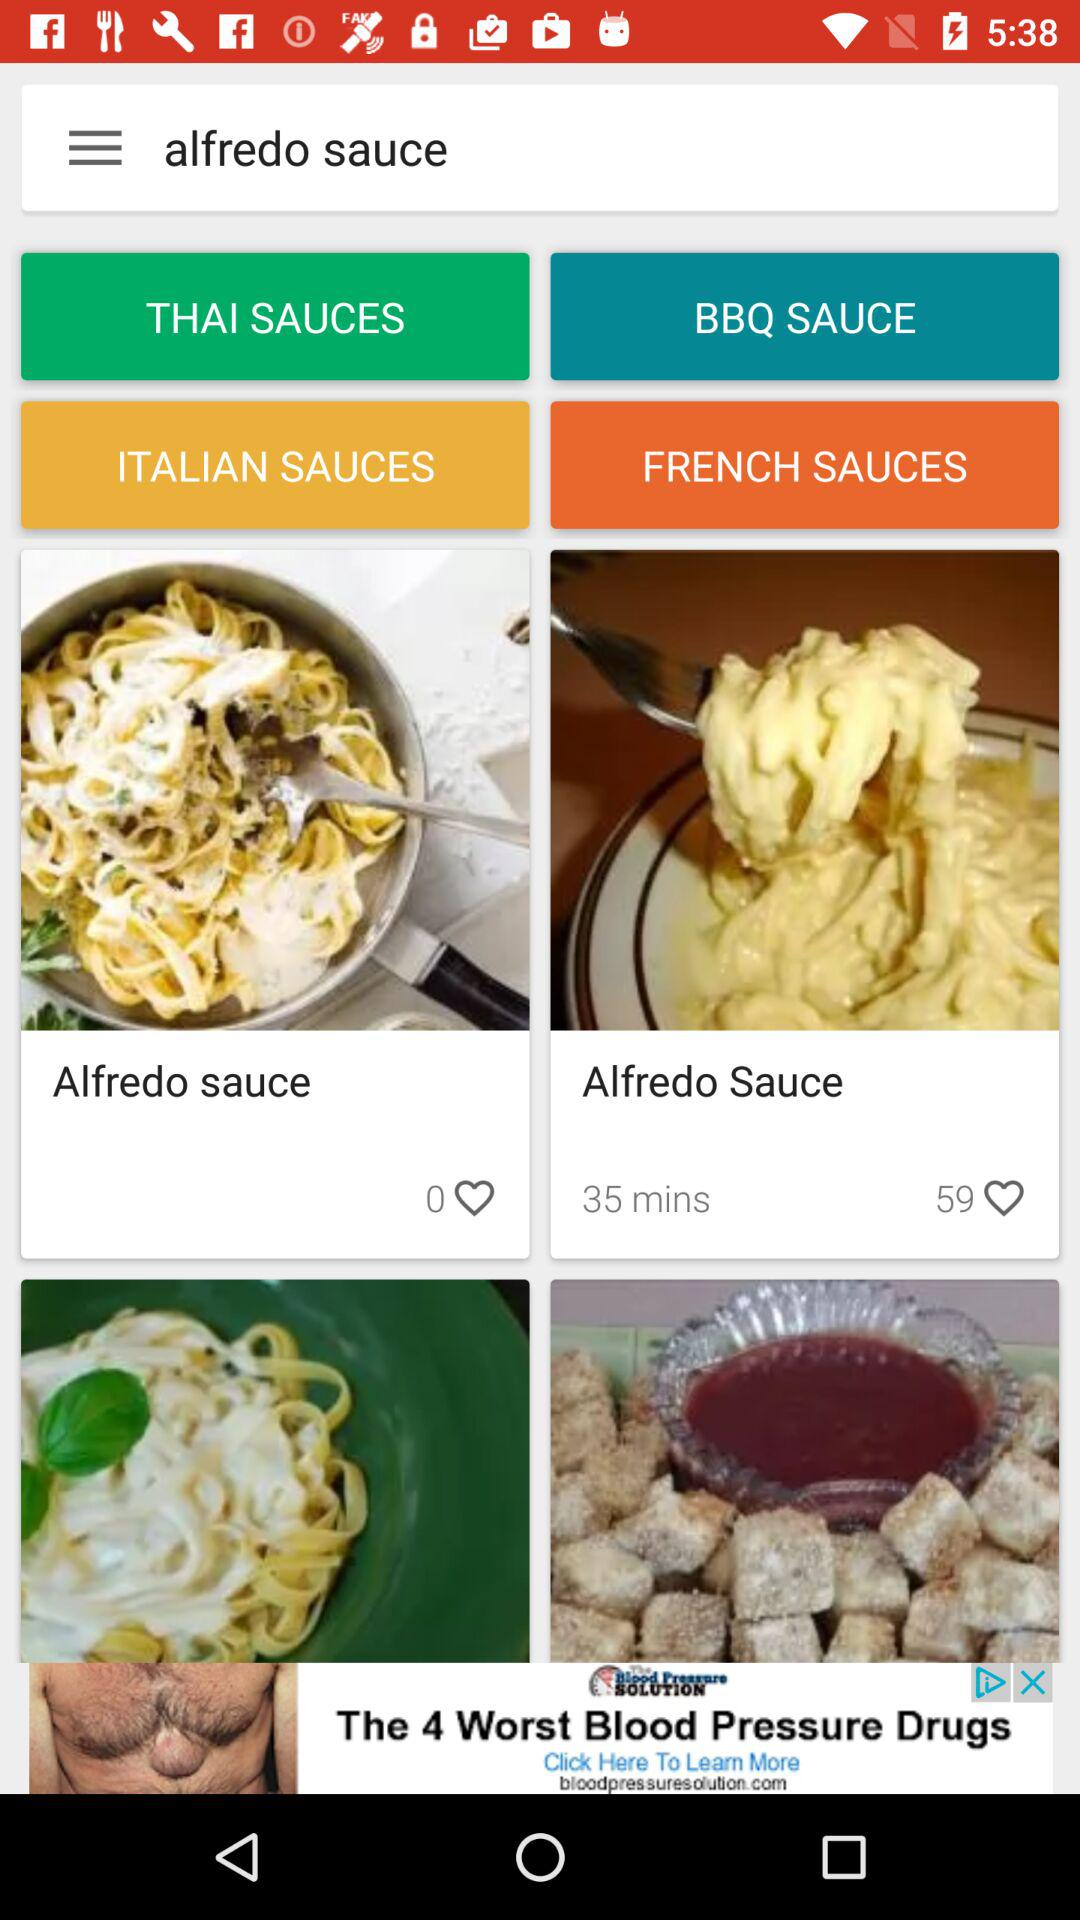How long does it take to make "Alfredo Sauce"? It takes 35 minutes to make "Alfredo Sauce". 